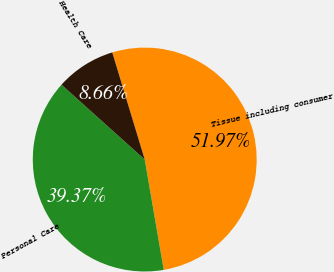Convert chart. <chart><loc_0><loc_0><loc_500><loc_500><pie_chart><fcel>Tissue including consumer<fcel>Personal Care<fcel>Health Care<nl><fcel>51.97%<fcel>39.37%<fcel>8.66%<nl></chart> 